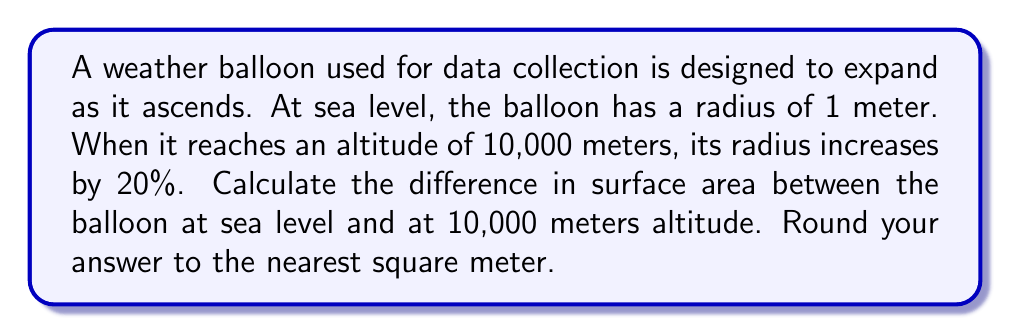Teach me how to tackle this problem. To solve this problem, we'll follow these steps:

1) The surface area of a sphere is given by the formula:
   $$A = 4\pi r^2$$
   where $A$ is the surface area and $r$ is the radius.

2) At sea level:
   Radius $r_1 = 1$ meter
   Surface area $A_1 = 4\pi (1)^2 = 4\pi$ square meters

3) At 10,000 meters:
   Radius $r_2 = 1 + 20\% = 1 + 0.2 = 1.2$ meters
   Surface area $A_2 = 4\pi (1.2)^2 = 4\pi (1.44) = 5.76\pi$ square meters

4) Difference in surface area:
   $$\Delta A = A_2 - A_1 = 5.76\pi - 4\pi = 1.76\pi$$ square meters

5) Converting to a numerical value and rounding:
   $$1.76\pi \approx 5.53$$ square meters

6) Rounding to the nearest square meter:
   $$5.53 \approx 6$$ square meters

Therefore, the difference in surface area is approximately 6 square meters.
Answer: 6 m² 